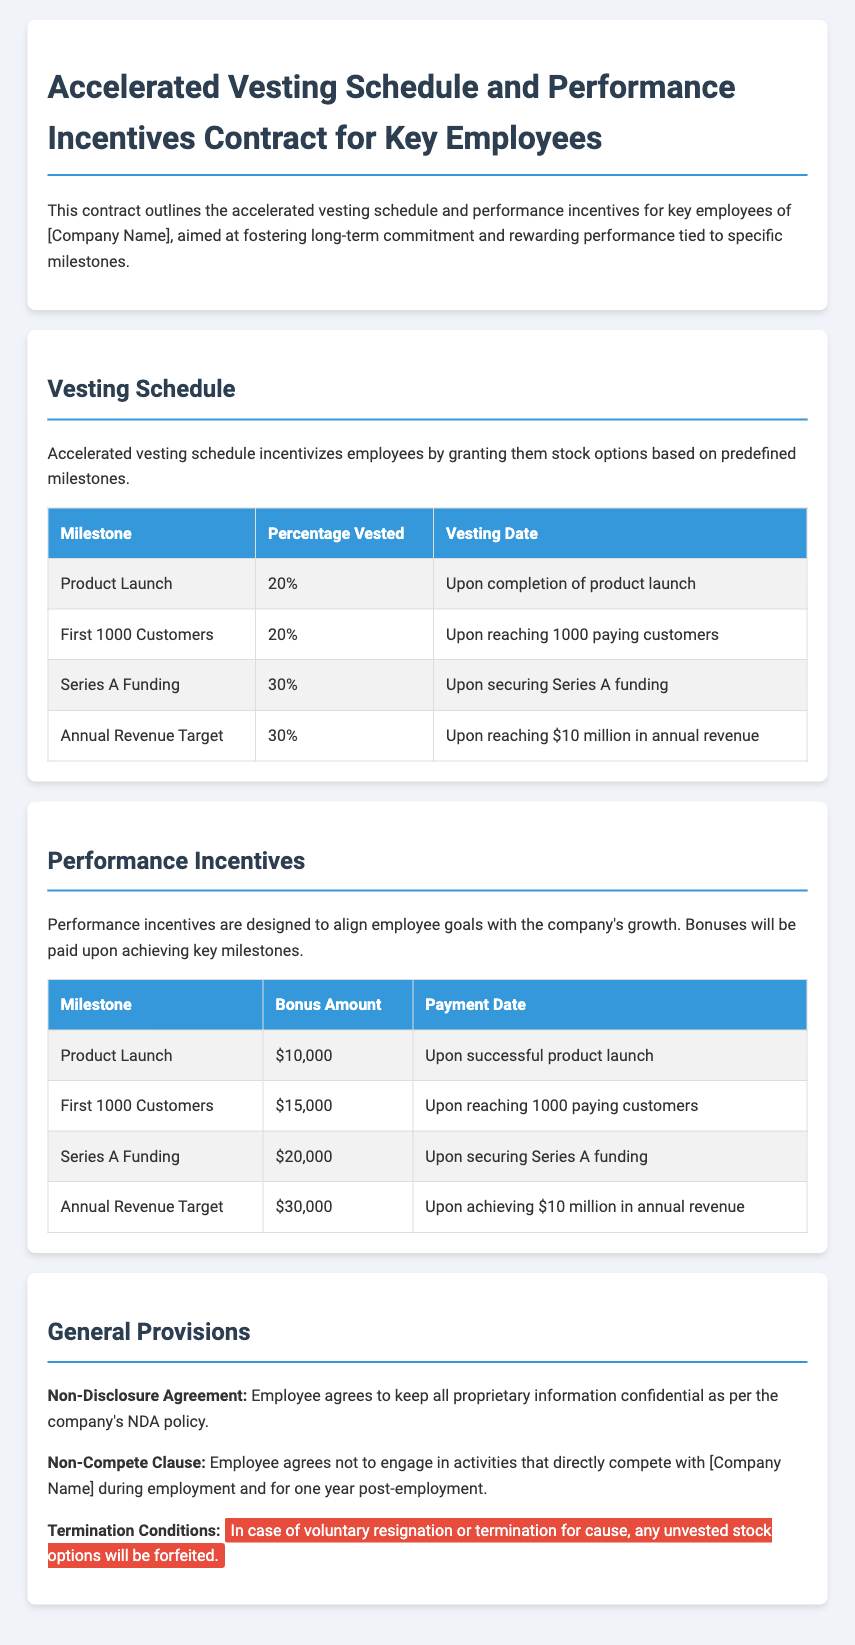What milestone is associated with a 20% vesting? The milestone for 20% vesting is the Product Launch, which is the first milestone listed in the vesting schedule.
Answer: Product Launch How much is the bonus for reaching 1000 customers? The bonus for reaching the milestone of the first 1000 customers is specifically stated as $15,000 in the performance incentives section.
Answer: $15,000 What percentage of stock options vests upon securing Series A funding? According to the vesting schedule, the percentage that vests upon securing Series A funding is mentioned as 30%.
Answer: 30% What is the payment date for the annual revenue target bonus? The contract specifies that the payment date for the annual revenue target bonus is upon achieving $10 million in annual revenue.
Answer: Upon achieving $10 million in annual revenue What happens to unvested stock options in case of voluntary resignation? The document highlights that in case of voluntary resignation or termination for cause, unvested stock options will be forfeited, according to the termination conditions.
Answer: Forfeited 